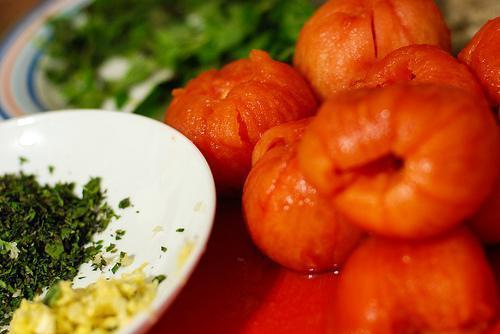How many plates are in the picture?
Give a very brief answer. 2. 